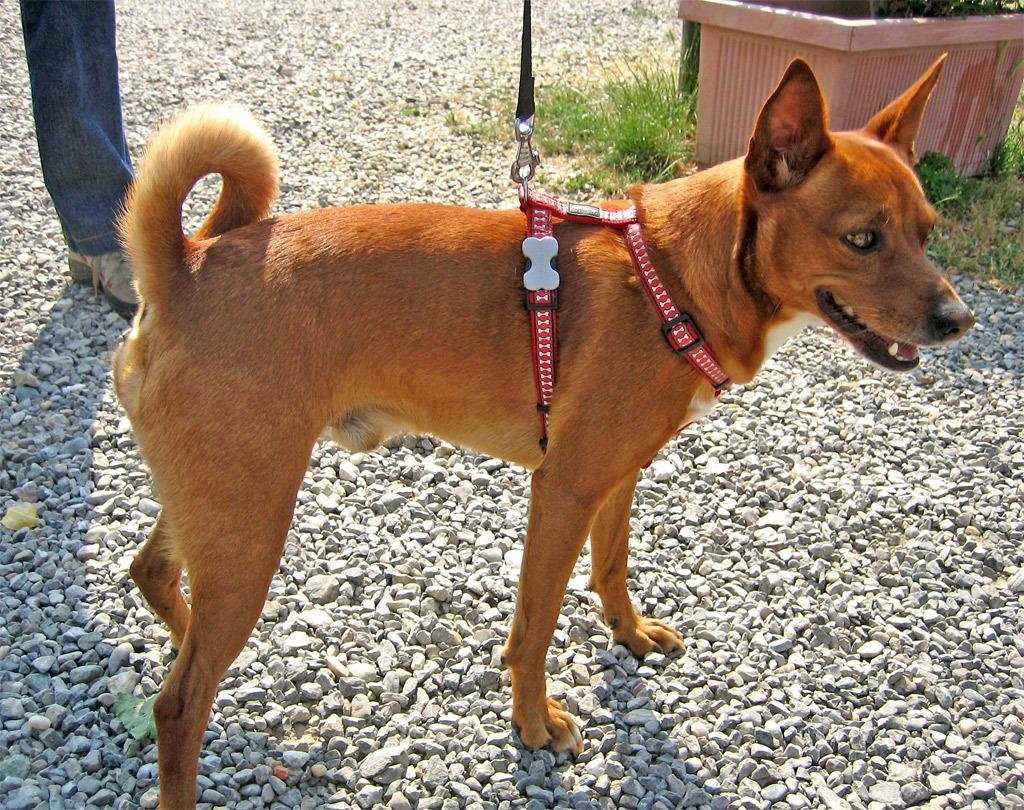What is the main subject in the middle of the image? There is a dog in the middle of the image. Can you describe the person in the background of the image? The person in the background of the image is wearing trousers and shoes. What type of vegetation is visible in the background of the image? There is grass in the background of the image. What other objects can be seen in the background of the image? There is a pot and stones visible in the background of the image. What type of fiction is the dog reading in the image? There is no indication in the image that the dog is reading any fiction in the image. 